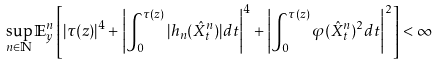<formula> <loc_0><loc_0><loc_500><loc_500>\sup _ { n \in \mathbb { N } } \mathbb { E } ^ { n } _ { y } \left [ | \tau ( z ) | ^ { 4 } + \left | \int _ { 0 } ^ { \tau ( z ) } | h _ { n } ( \hat { X } ^ { n } _ { t } ) | d t \right | ^ { 4 } + \left | \int _ { 0 } ^ { \tau ( z ) } \varphi ( \hat { X } ^ { n } _ { t } ) ^ { 2 } d t \right | ^ { 2 } \right ] < \infty</formula> 